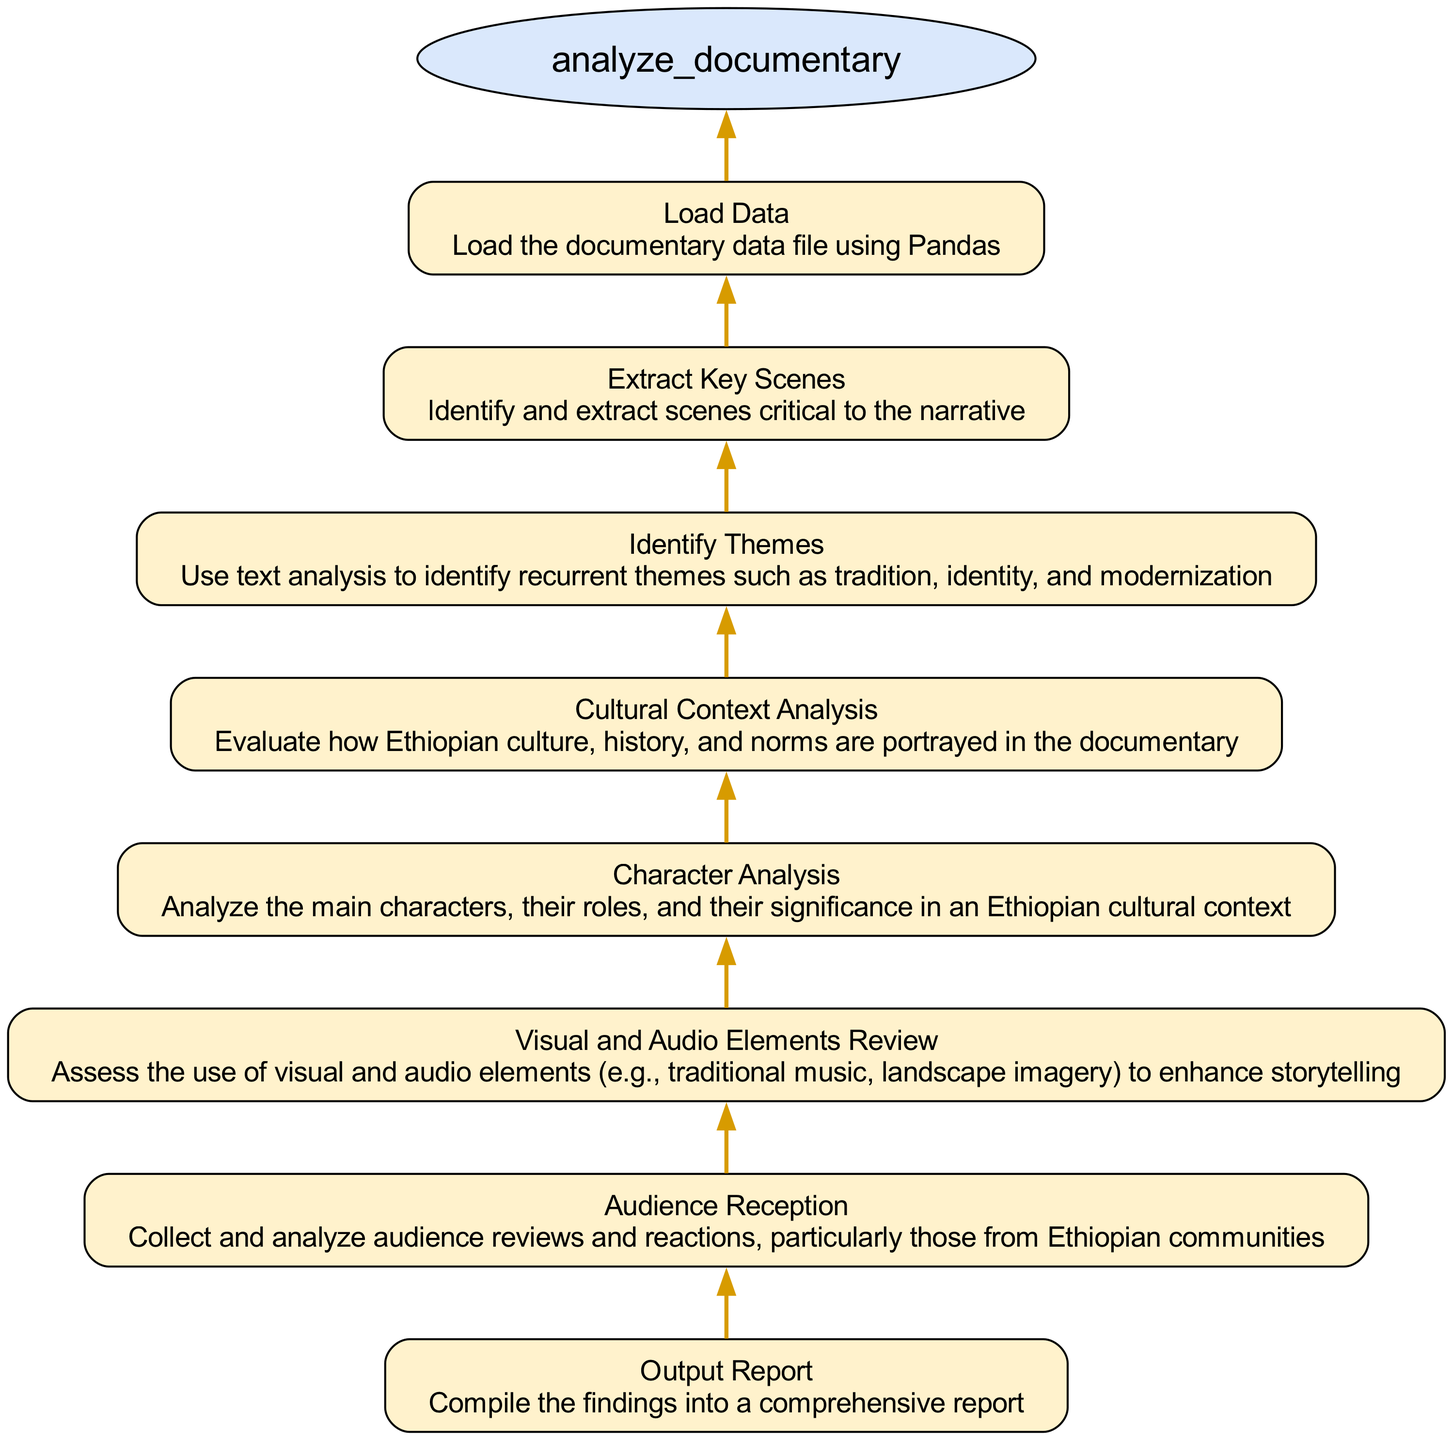What is the first step in the analysis process? The first step, located at the bottom of the flowchart, is "Load Data," which indicates that the documentary data file should be loaded using Pandas.
Answer: Load Data How many elements are there in this flowchart? By counting the nodes in the flowchart, there are eight elements that describe the steps in analyzing the documentary.
Answer: Eight What is analyzed after identifying themes? According to the flow of the diagram, "Cultural Context Analysis" is the subsequent step after "Identify Themes," indicating that this analysis follows the theme identification.
Answer: Cultural Context Analysis Which element comes before “Output Report”? "Audience Reception" directly precedes "Output Report," as indicated by the flow from the audience analysis step to the final reporting step in the diagram.
Answer: Audience Reception What method is used to analyze key scenes? The diagram mentions "Extract Key Scenes," which involves identifying and extracting the scenes critical to the documentary's narrative, suggesting a methodical approach.
Answer: Extract Key Scenes How does the analysis of visual and audio elements relate to cultural insights? The "Visual and Audio Elements Review" step evaluates the use of these elements in storytelling; this implies that understanding how these components represent cultural insights is part of the analysis process.
Answer: The elements enhance storytelling What is the significance of character analysis in this flowchart? The flowchart specifies "Character Analysis" as a dedicated element, indicating its importance in assessing the significance of characters within the context of Ethiopian culture.
Answer: Analyze the main characters What type of data will be analyzed to gauge audience reception? The flowchart specifies that audience reviews and reactions, particularly from Ethiopian communities, will be collected and analyzed to gauge reception, highlighting the cultural specificity of the feedback.
Answer: Audience reviews and reactions 